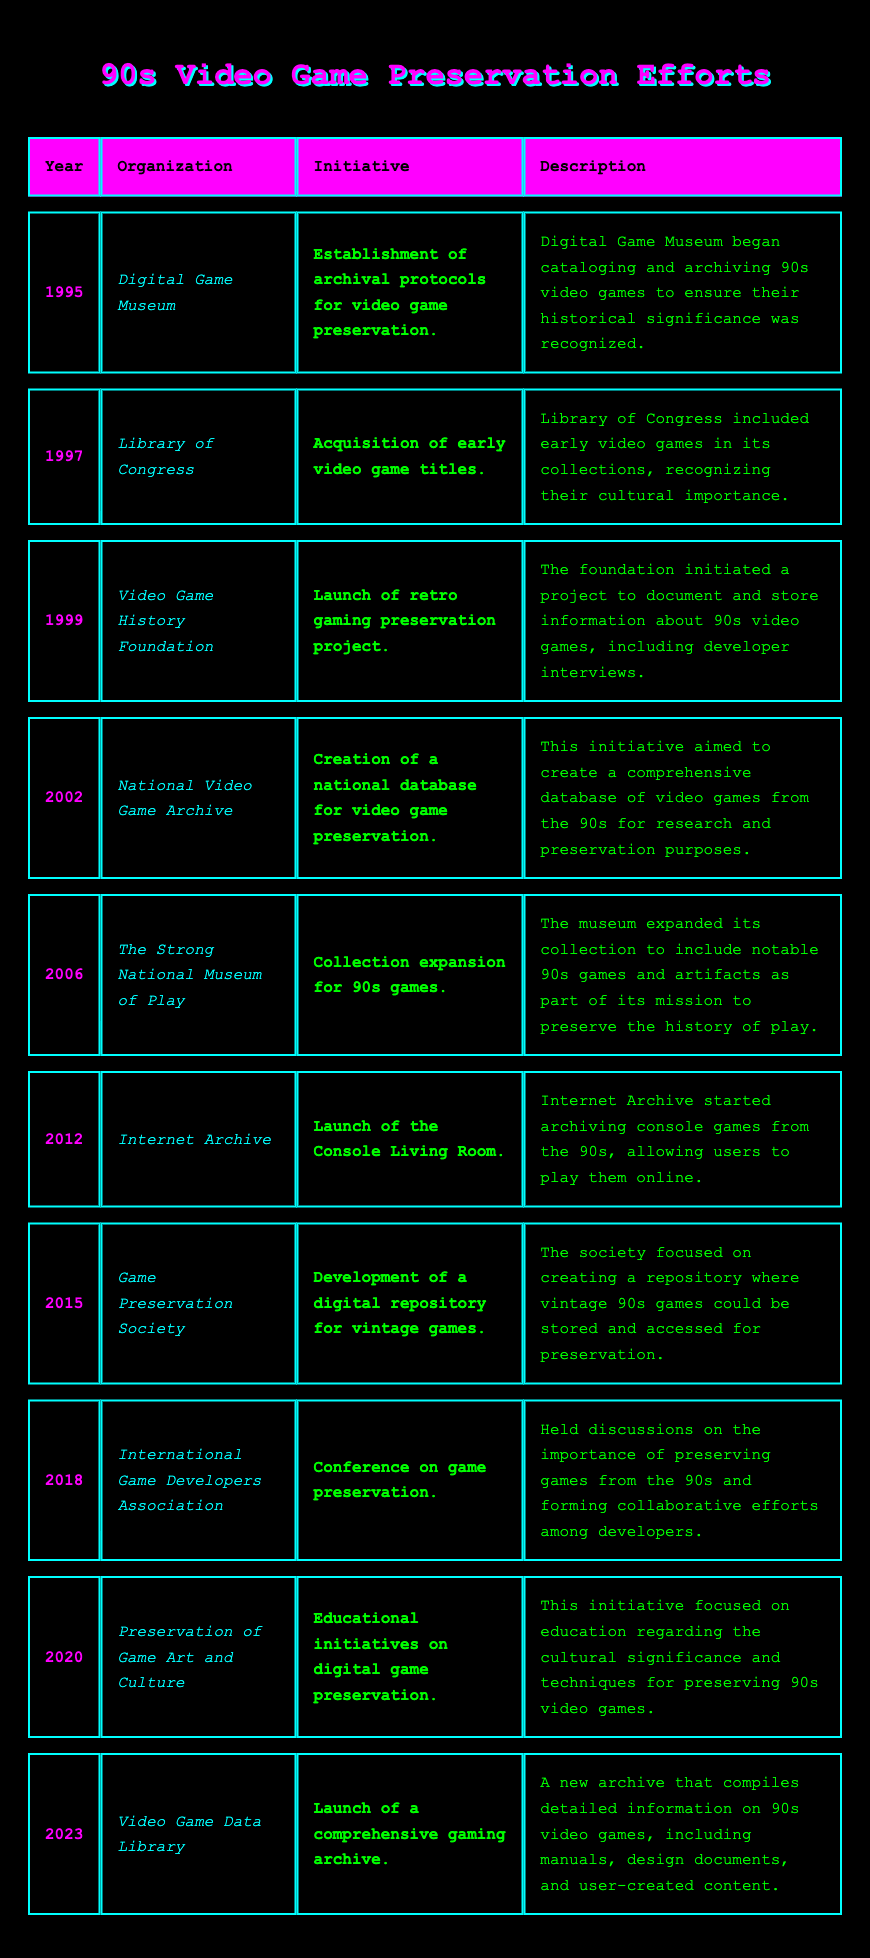What initiative did the Digital Game Museum undertake in 1995? The table shows that in 1995, the Digital Game Museum established archival protocols for video game preservation.
Answer: Establishment of archival protocols for video game preservation Which organization acquired early video game titles in 1997? According to the table, the Library of Congress acquired early video game titles in 1997.
Answer: Library of Congress What year did the Video Game History Foundation launch its retro gaming preservation project? The table indicates that the Video Game History Foundation launched its retro gaming preservation project in 1999.
Answer: 1999 How many preservation initiatives were launched between 1995 and 2000? From the table, there are four initiatives listed between 1995 and 2000 (1995, 1997, 1999).
Answer: 4 What was the main goal of the National Video Game Archive's initiative in 2002? The initiative in 2002 aimed to create a comprehensive database of video games from the 90s for research and preservation.
Answer: To create a comprehensive database for preservation Was the Console Living Room initiative by Internet Archive started before or after 2010? The table shows that the Console Living Room initiative started in 2012, indicating it was after 2010.
Answer: After 2010 List the three organizations that undertook initiatives focused on game preservation in the 2010s. Based on the table, the organizations in the 2010s are the Internet Archive in 2012, Game Preservation Society in 2015, and Preservation of Game Art and Culture in 2020.
Answer: Internet Archive, Game Preservation Society, Preservation of Game Art and Culture How many years passed between the establishment of the Digital Game Museum initiative and the launch of the Console Living Room? The Digital Game Museum initiative was in 1995 and the Console Living Room was in 2012. The difference is 2012 - 1995 = 17 years.
Answer: 17 years Which organization held a conference on game preservation in 2018? The table states that the International Game Developers Association held a conference on game preservation in 2018.
Answer: International Game Developers Association What is the primary focus of the initiative launched by the Video Game Data Library in 2023? The initiative focuses on launching a comprehensive gaming archive that compiles detailed information on 90s video games.
Answer: Launch of a comprehensive gaming archive What was a common theme of many preservation efforts in the 90s and early 2000s? The common theme evident in multiple entries is the recognition of video games' cultural significance and the need to archive them.
Answer: Recognition of cultural significance 